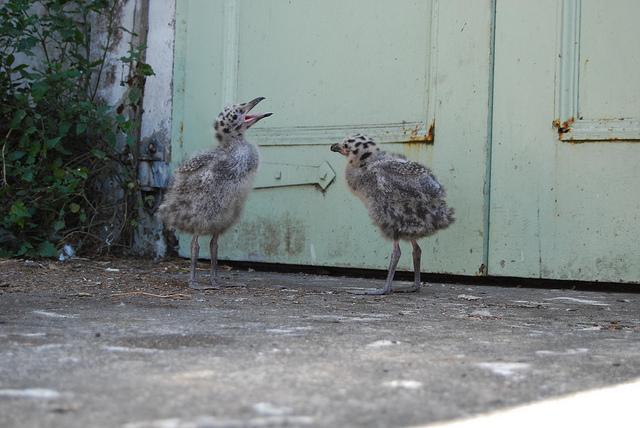How many birds are here?
Give a very brief answer. 2. How many birds are the same color?
Give a very brief answer. 2. How many birds?
Give a very brief answer. 2. How many birds can you see?
Give a very brief answer. 2. 